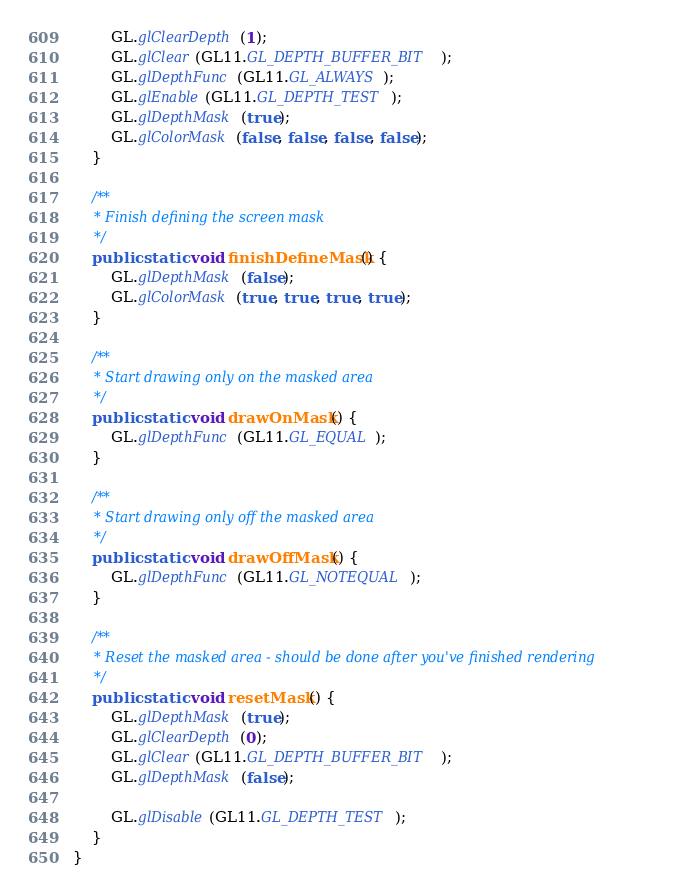Convert code to text. <code><loc_0><loc_0><loc_500><loc_500><_Java_>        GL.glClearDepth(1);
        GL.glClear(GL11.GL_DEPTH_BUFFER_BIT);
        GL.glDepthFunc(GL11.GL_ALWAYS);
        GL.glEnable(GL11.GL_DEPTH_TEST);
        GL.glDepthMask(true);
        GL.glColorMask(false, false, false, false);
    }

    /**
     * Finish defining the screen mask
     */
    public static void finishDefineMask() {
        GL.glDepthMask(false);
        GL.glColorMask(true, true, true, true);
    }

    /**
     * Start drawing only on the masked area
     */
    public static void drawOnMask() {
        GL.glDepthFunc(GL11.GL_EQUAL);
    }

    /**
     * Start drawing only off the masked area
     */
    public static void drawOffMask() {
        GL.glDepthFunc(GL11.GL_NOTEQUAL);
    }

    /**
     * Reset the masked area - should be done after you've finished rendering
     */
    public static void resetMask() {
        GL.glDepthMask(true);
        GL.glClearDepth(0);
        GL.glClear(GL11.GL_DEPTH_BUFFER_BIT);
        GL.glDepthMask(false);

        GL.glDisable(GL11.GL_DEPTH_TEST);
    }
}
</code> 